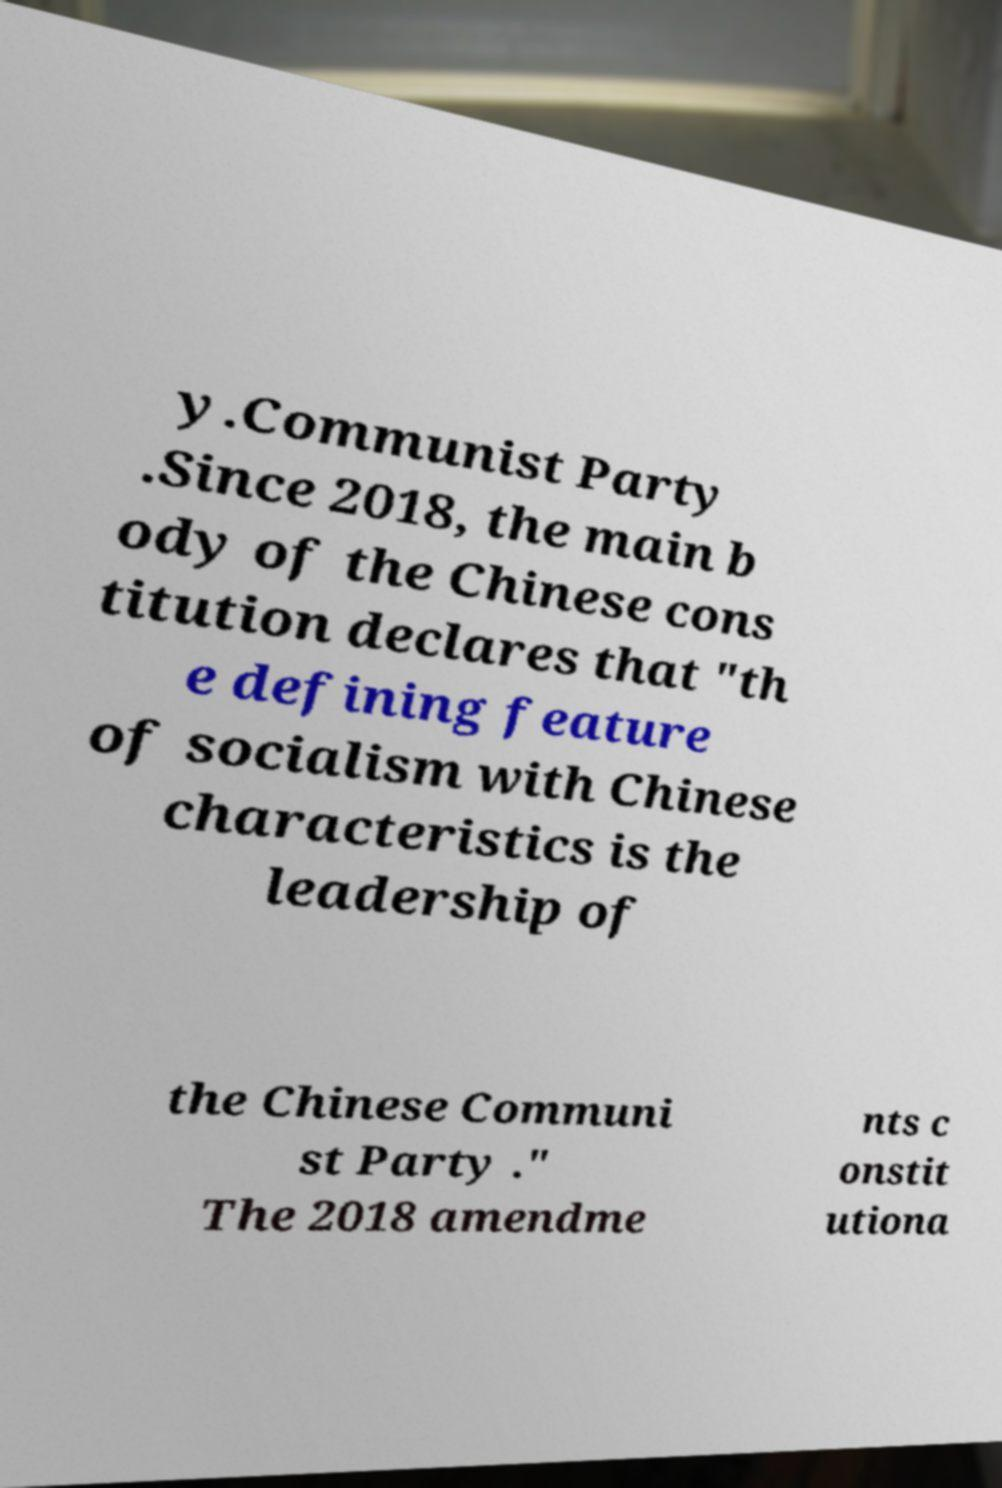Can you accurately transcribe the text from the provided image for me? y.Communist Party .Since 2018, the main b ody of the Chinese cons titution declares that "th e defining feature of socialism with Chinese characteristics is the leadership of the Chinese Communi st Party ." The 2018 amendme nts c onstit utiona 